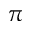Convert formula to latex. <formula><loc_0><loc_0><loc_500><loc_500>\pi</formula> 